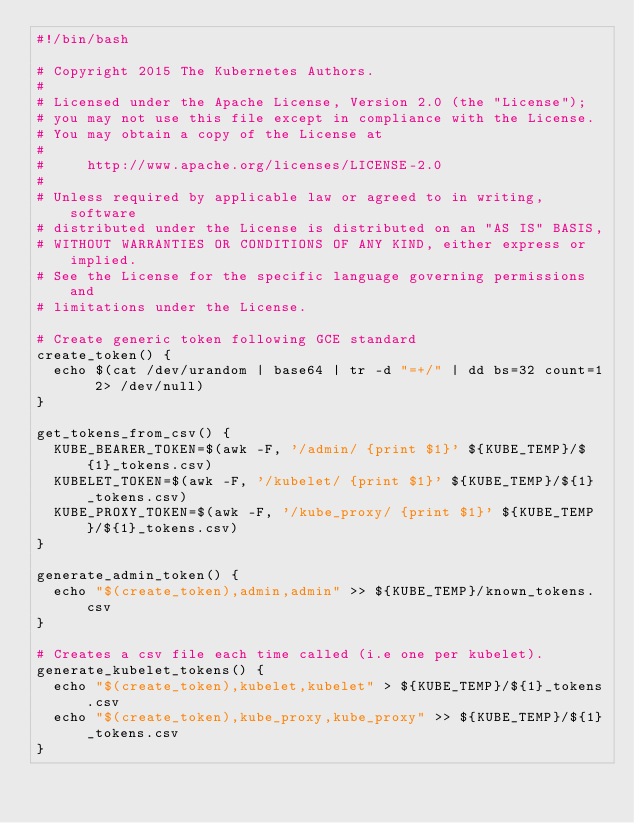Convert code to text. <code><loc_0><loc_0><loc_500><loc_500><_Bash_>#!/bin/bash

# Copyright 2015 The Kubernetes Authors.
#
# Licensed under the Apache License, Version 2.0 (the "License");
# you may not use this file except in compliance with the License.
# You may obtain a copy of the License at
#
#     http://www.apache.org/licenses/LICENSE-2.0
#
# Unless required by applicable law or agreed to in writing, software
# distributed under the License is distributed on an "AS IS" BASIS,
# WITHOUT WARRANTIES OR CONDITIONS OF ANY KIND, either express or implied.
# See the License for the specific language governing permissions and
# limitations under the License.

# Create generic token following GCE standard
create_token() {
  echo $(cat /dev/urandom | base64 | tr -d "=+/" | dd bs=32 count=1 2> /dev/null)
}

get_tokens_from_csv() {
  KUBE_BEARER_TOKEN=$(awk -F, '/admin/ {print $1}' ${KUBE_TEMP}/${1}_tokens.csv)
  KUBELET_TOKEN=$(awk -F, '/kubelet/ {print $1}' ${KUBE_TEMP}/${1}_tokens.csv)
  KUBE_PROXY_TOKEN=$(awk -F, '/kube_proxy/ {print $1}' ${KUBE_TEMP}/${1}_tokens.csv)
}

generate_admin_token() {
  echo "$(create_token),admin,admin" >> ${KUBE_TEMP}/known_tokens.csv
}

# Creates a csv file each time called (i.e one per kubelet).
generate_kubelet_tokens() {
  echo "$(create_token),kubelet,kubelet" > ${KUBE_TEMP}/${1}_tokens.csv
  echo "$(create_token),kube_proxy,kube_proxy" >> ${KUBE_TEMP}/${1}_tokens.csv
}
</code> 